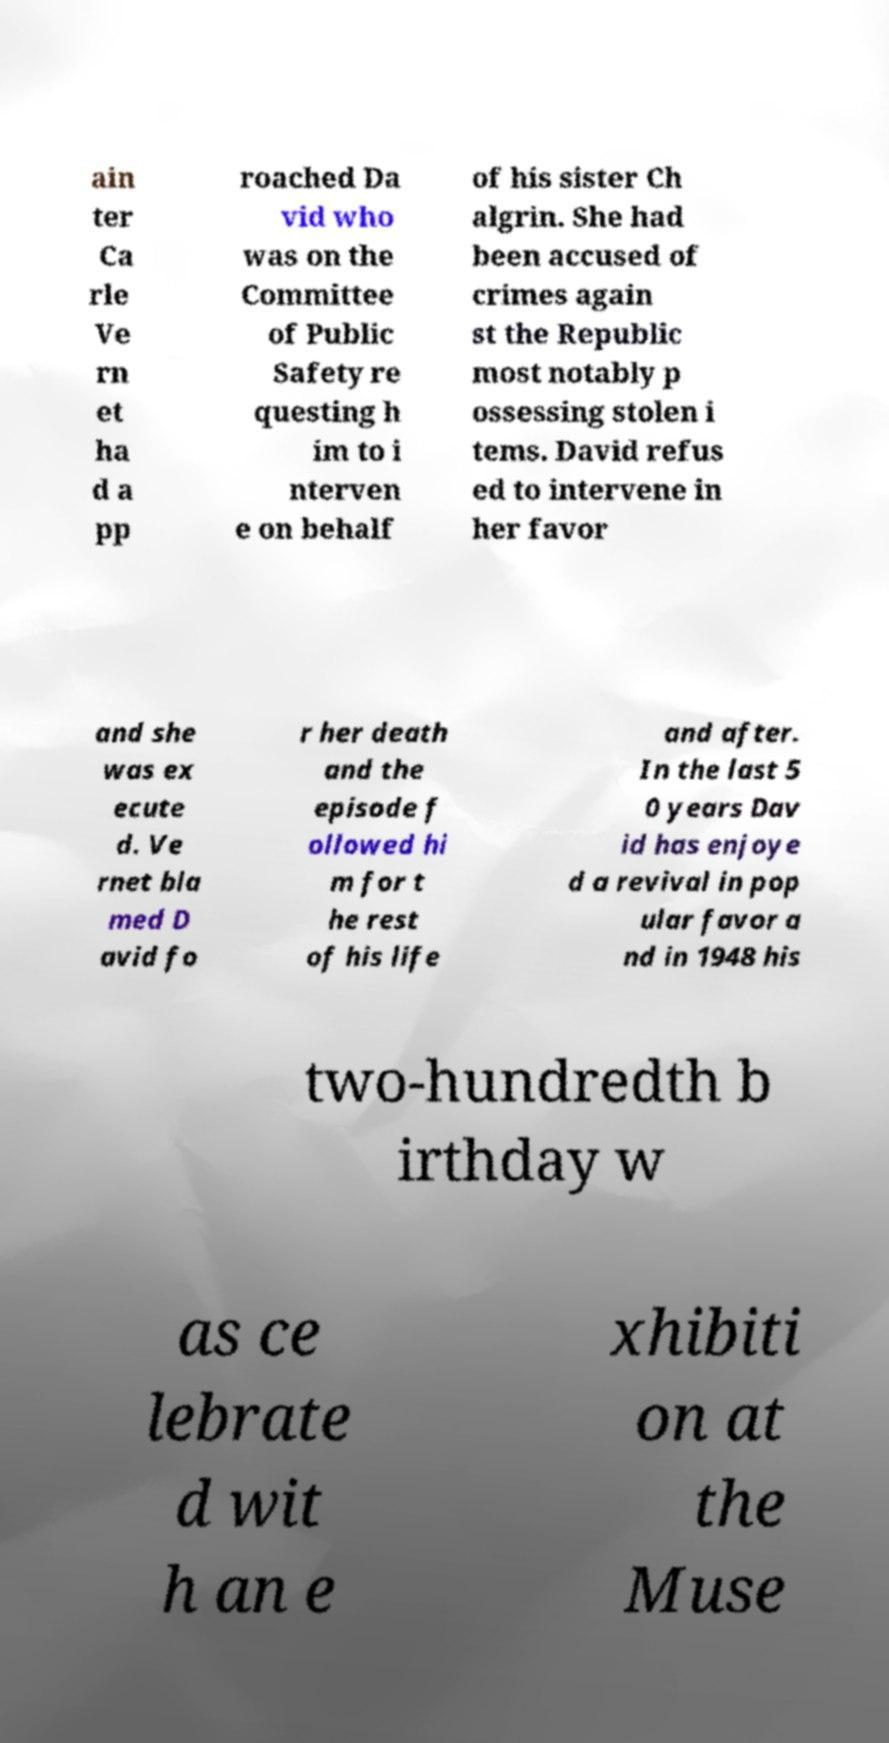Can you accurately transcribe the text from the provided image for me? ain ter Ca rle Ve rn et ha d a pp roached Da vid who was on the Committee of Public Safety re questing h im to i nterven e on behalf of his sister Ch algrin. She had been accused of crimes again st the Republic most notably p ossessing stolen i tems. David refus ed to intervene in her favor and she was ex ecute d. Ve rnet bla med D avid fo r her death and the episode f ollowed hi m for t he rest of his life and after. In the last 5 0 years Dav id has enjoye d a revival in pop ular favor a nd in 1948 his two-hundredth b irthday w as ce lebrate d wit h an e xhibiti on at the Muse 